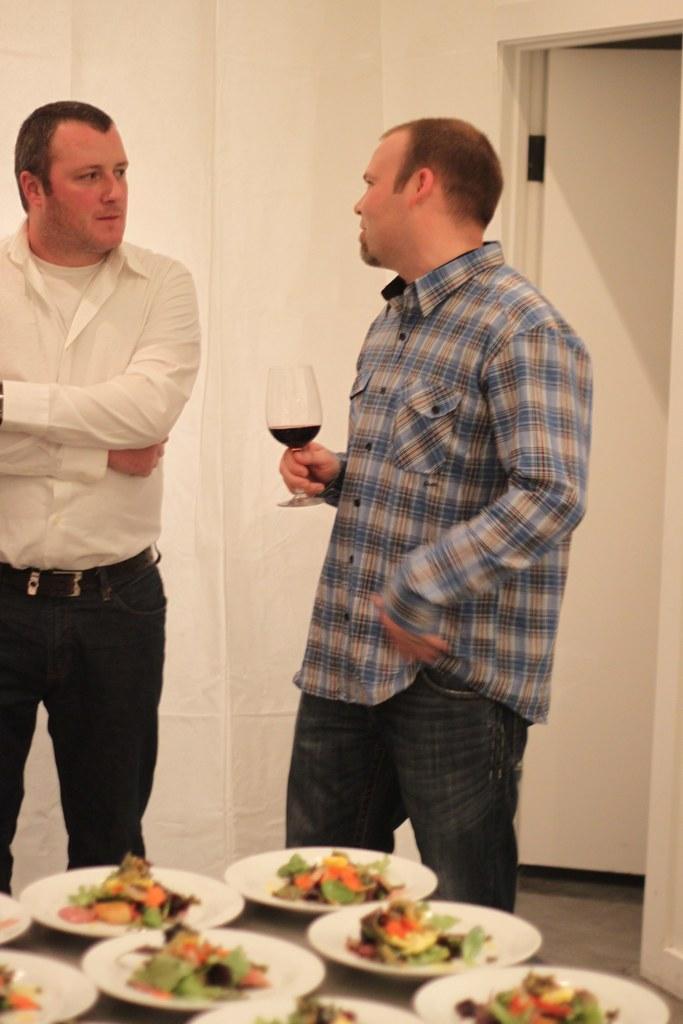In one or two sentences, can you explain what this image depicts? In this image i can see 2 persons standing, the person on the right side is wearing a blue shirt and jeans and holding a glass in his hands and the person on the left side is wearing a white shirt and black pant. I can see a table on which there are few plate with food items in them. In the background i can see the wall and the door. 